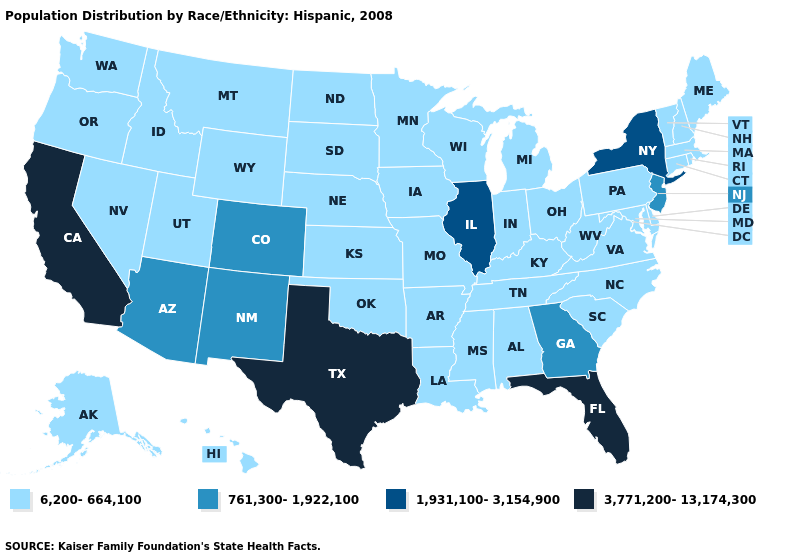What is the value of Kansas?
Short answer required. 6,200-664,100. Does the first symbol in the legend represent the smallest category?
Write a very short answer. Yes. Name the states that have a value in the range 3,771,200-13,174,300?
Concise answer only. California, Florida, Texas. What is the highest value in states that border Colorado?
Write a very short answer. 761,300-1,922,100. Name the states that have a value in the range 3,771,200-13,174,300?
Answer briefly. California, Florida, Texas. What is the lowest value in states that border Colorado?
Write a very short answer. 6,200-664,100. What is the value of Arizona?
Be succinct. 761,300-1,922,100. Which states have the highest value in the USA?
Write a very short answer. California, Florida, Texas. Which states have the highest value in the USA?
Write a very short answer. California, Florida, Texas. What is the value of Kansas?
Quick response, please. 6,200-664,100. What is the highest value in the West ?
Concise answer only. 3,771,200-13,174,300. How many symbols are there in the legend?
Answer briefly. 4. Name the states that have a value in the range 761,300-1,922,100?
Answer briefly. Arizona, Colorado, Georgia, New Jersey, New Mexico. What is the value of Georgia?
Short answer required. 761,300-1,922,100. What is the value of Texas?
Give a very brief answer. 3,771,200-13,174,300. 